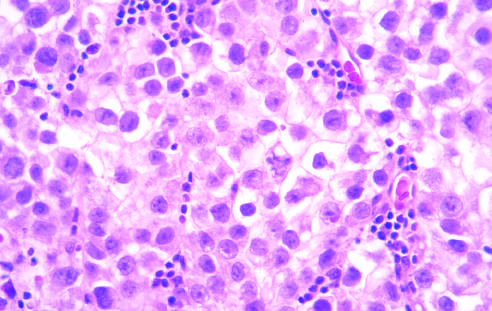does microscopic examination reveal large cells with distinct cell borders, pale nuclei, prominent nucleoli, and a sparse lymphocytic infiltrate?
Answer the question using a single word or phrase. Yes 